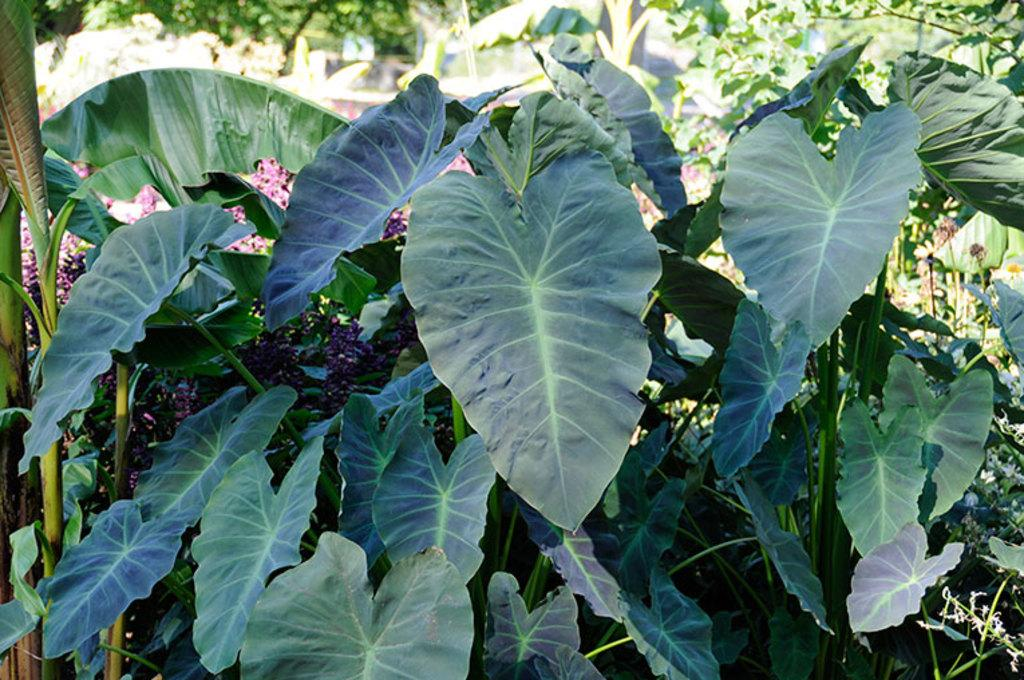What is the primary subject of the image? The primary subject of the image is many plants. Can you describe the plants in the image? Unfortunately, the facts provided do not give specific details about the plants. However, we can say that there are multiple plants visible in the image. What type of pencil can be seen in the image? There is no pencil present in the image; it features many plants. How does the hen interact with the plants in the image? There is no hen present in the image; it only contains plants. 